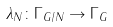Convert formula to latex. <formula><loc_0><loc_0><loc_500><loc_500>\lambda _ { N } \colon \Gamma _ { G / N } \to \Gamma _ { G }</formula> 